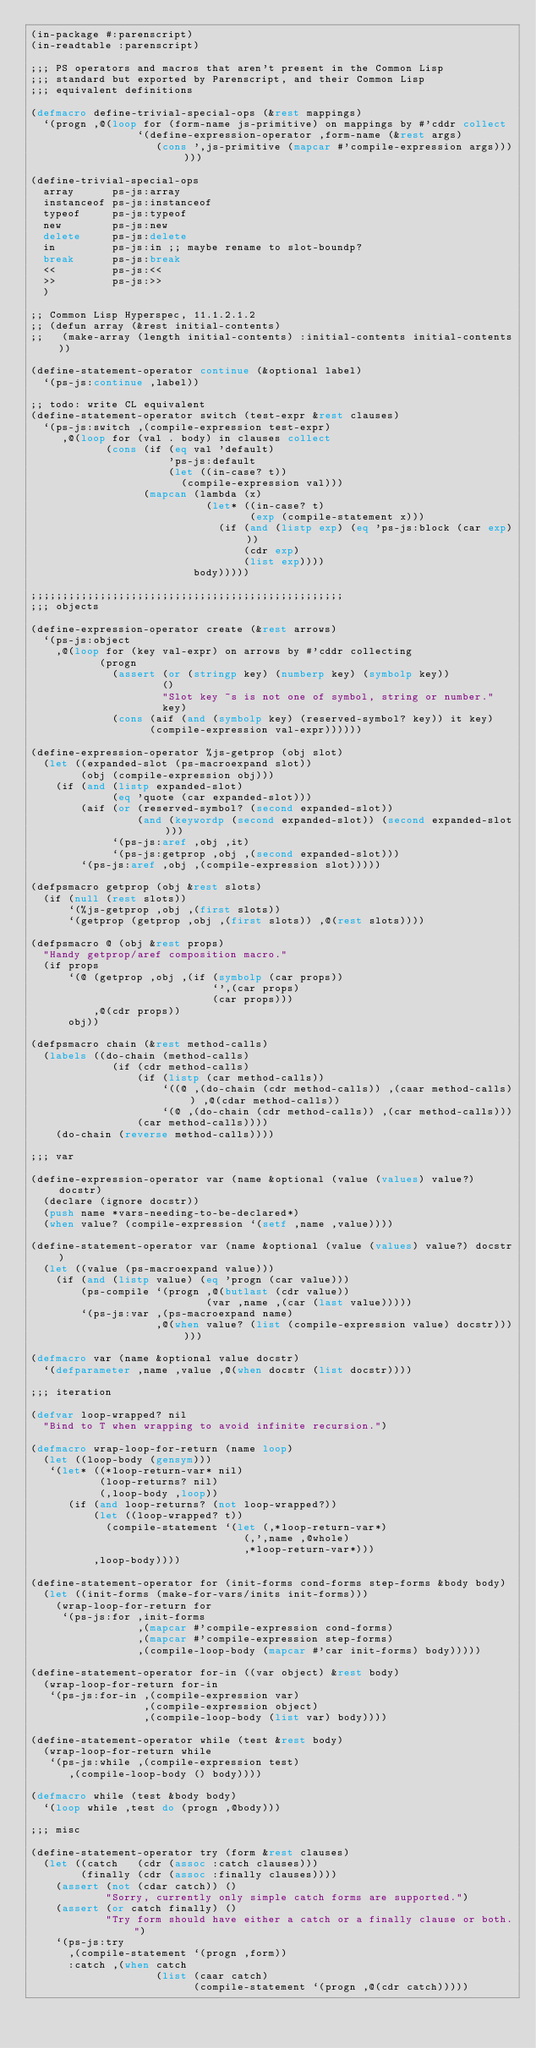<code> <loc_0><loc_0><loc_500><loc_500><_Lisp_>(in-package #:parenscript)
(in-readtable :parenscript)

;;; PS operators and macros that aren't present in the Common Lisp
;;; standard but exported by Parenscript, and their Common Lisp
;;; equivalent definitions

(defmacro define-trivial-special-ops (&rest mappings)
  `(progn ,@(loop for (form-name js-primitive) on mappings by #'cddr collect
                 `(define-expression-operator ,form-name (&rest args)
                    (cons ',js-primitive (mapcar #'compile-expression args))))))

(define-trivial-special-ops
  array      ps-js:array
  instanceof ps-js:instanceof
  typeof     ps-js:typeof
  new        ps-js:new
  delete     ps-js:delete
  in         ps-js:in ;; maybe rename to slot-boundp?
  break      ps-js:break
  <<         ps-js:<<
  >>         ps-js:>>
  )

;; Common Lisp Hyperspec, 11.1.2.1.2
;; (defun array (&rest initial-contents)
;;   (make-array (length initial-contents) :initial-contents initial-contents))

(define-statement-operator continue (&optional label)
  `(ps-js:continue ,label))

;; todo: write CL equivalent
(define-statement-operator switch (test-expr &rest clauses)
  `(ps-js:switch ,(compile-expression test-expr)
     ,@(loop for (val . body) in clauses collect
            (cons (if (eq val 'default)
                      'ps-js:default
                      (let ((in-case? t))
                        (compile-expression val)))
                  (mapcan (lambda (x)
                            (let* ((in-case? t)
                                   (exp (compile-statement x)))
                              (if (and (listp exp) (eq 'ps-js:block (car exp)))
                                  (cdr exp)
                                  (list exp))))
                          body)))))

;;;;;;;;;;;;;;;;;;;;;;;;;;;;;;;;;;;;;;;;;;;;;;;;;;
;;; objects

(define-expression-operator create (&rest arrows)
  `(ps-js:object
    ,@(loop for (key val-expr) on arrows by #'cddr collecting
           (progn
             (assert (or (stringp key) (numberp key) (symbolp key))
                     ()
                     "Slot key ~s is not one of symbol, string or number."
                     key)
             (cons (aif (and (symbolp key) (reserved-symbol? key)) it key)
                   (compile-expression val-expr))))))

(define-expression-operator %js-getprop (obj slot)
  (let ((expanded-slot (ps-macroexpand slot))
        (obj (compile-expression obj)))
    (if (and (listp expanded-slot)
             (eq 'quote (car expanded-slot)))
        (aif (or (reserved-symbol? (second expanded-slot))
                 (and (keywordp (second expanded-slot)) (second expanded-slot)))
             `(ps-js:aref ,obj ,it)
             `(ps-js:getprop ,obj ,(second expanded-slot)))
        `(ps-js:aref ,obj ,(compile-expression slot)))))

(defpsmacro getprop (obj &rest slots)
  (if (null (rest slots))
      `(%js-getprop ,obj ,(first slots))
      `(getprop (getprop ,obj ,(first slots)) ,@(rest slots))))

(defpsmacro @ (obj &rest props)
  "Handy getprop/aref composition macro."
  (if props
      `(@ (getprop ,obj ,(if (symbolp (car props))
                             `',(car props)
                             (car props)))
          ,@(cdr props))
      obj))

(defpsmacro chain (&rest method-calls)
  (labels ((do-chain (method-calls)
             (if (cdr method-calls)
                 (if (listp (car method-calls))
                     `((@ ,(do-chain (cdr method-calls)) ,(caar method-calls)) ,@(cdar method-calls))
                     `(@ ,(do-chain (cdr method-calls)) ,(car method-calls)))
                 (car method-calls))))
    (do-chain (reverse method-calls))))

;;; var

(define-expression-operator var (name &optional (value (values) value?) docstr)
  (declare (ignore docstr))
  (push name *vars-needing-to-be-declared*)
  (when value? (compile-expression `(setf ,name ,value))))

(define-statement-operator var (name &optional (value (values) value?) docstr)
  (let ((value (ps-macroexpand value)))
    (if (and (listp value) (eq 'progn (car value)))
        (ps-compile `(progn ,@(butlast (cdr value))
                            (var ,name ,(car (last value)))))
        `(ps-js:var ,(ps-macroexpand name)
                    ,@(when value? (list (compile-expression value) docstr))))))

(defmacro var (name &optional value docstr)
  `(defparameter ,name ,value ,@(when docstr (list docstr))))

;;; iteration

(defvar loop-wrapped? nil
  "Bind to T when wrapping to avoid infinite recursion.")

(defmacro wrap-loop-for-return (name loop)
  (let ((loop-body (gensym)))
   `(let* ((*loop-return-var* nil)
           (loop-returns? nil)
           (,loop-body ,loop))
      (if (and loop-returns? (not loop-wrapped?))
          (let ((loop-wrapped? t))
            (compile-statement `(let (,*loop-return-var*)
                                  (,',name ,@whole)
                                  ,*loop-return-var*)))
          ,loop-body))))

(define-statement-operator for (init-forms cond-forms step-forms &body body)
  (let ((init-forms (make-for-vars/inits init-forms)))
    (wrap-loop-for-return for
     `(ps-js:for ,init-forms
                 ,(mapcar #'compile-expression cond-forms)
                 ,(mapcar #'compile-expression step-forms)
                 ,(compile-loop-body (mapcar #'car init-forms) body)))))

(define-statement-operator for-in ((var object) &rest body)
  (wrap-loop-for-return for-in
   `(ps-js:for-in ,(compile-expression var)
                  ,(compile-expression object)
                  ,(compile-loop-body (list var) body))))

(define-statement-operator while (test &rest body)
  (wrap-loop-for-return while
   `(ps-js:while ,(compile-expression test)
      ,(compile-loop-body () body))))

(defmacro while (test &body body)
  `(loop while ,test do (progn ,@body)))

;;; misc

(define-statement-operator try (form &rest clauses)
  (let ((catch   (cdr (assoc :catch clauses)))
        (finally (cdr (assoc :finally clauses))))
    (assert (not (cdar catch)) ()
            "Sorry, currently only simple catch forms are supported.")
    (assert (or catch finally) ()
            "Try form should have either a catch or a finally clause or both.")
    `(ps-js:try
      ,(compile-statement `(progn ,form))
      :catch ,(when catch
                    (list (caar catch)
                          (compile-statement `(progn ,@(cdr catch)))))</code> 